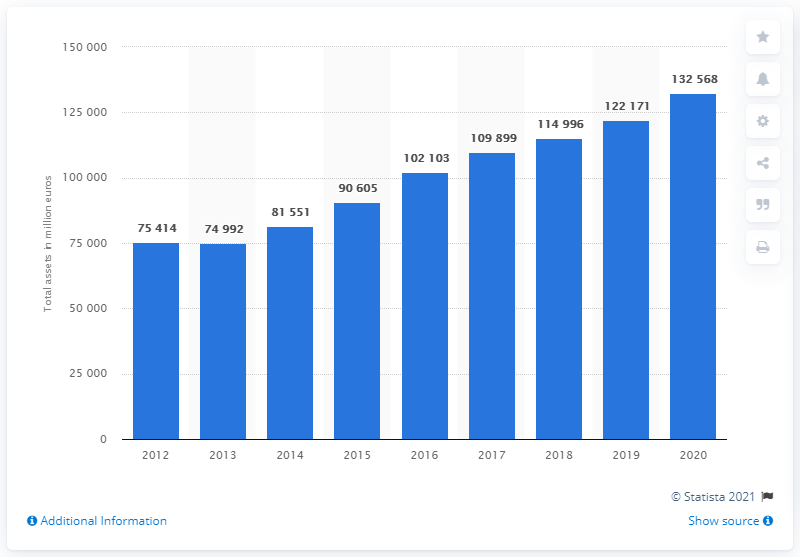Point out several critical features in this image. As of 2020, Renault Group's total assets have come to an end. According to the fiscal year of 2020, the value of Renault Group's total assets was 132,568. Renault Group's last fiscal year was in 2012. 